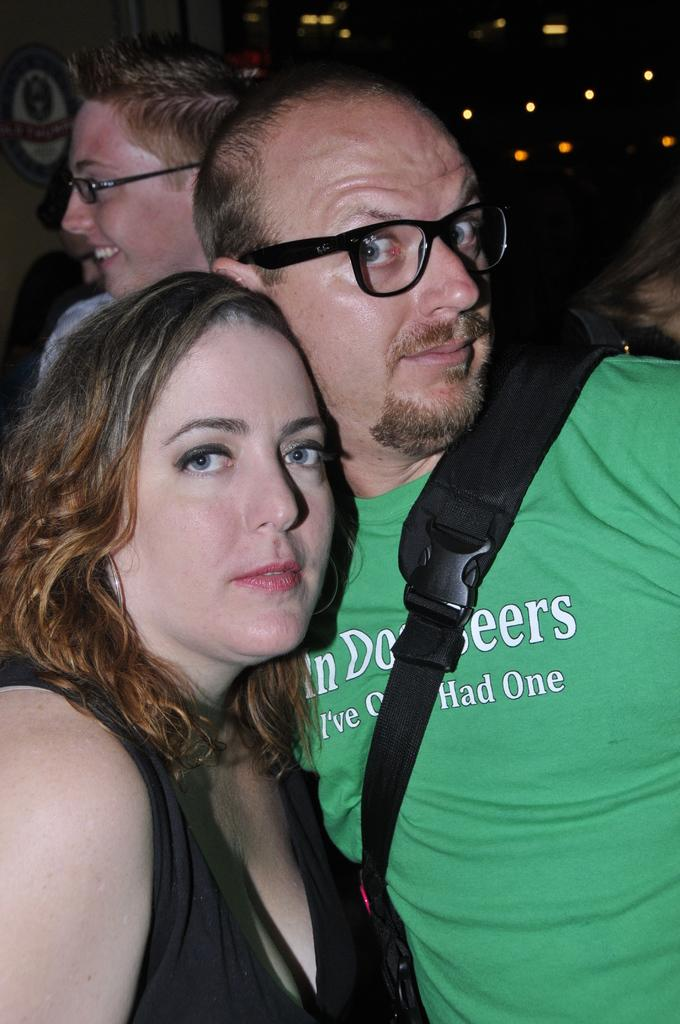How many people are present in the image? There is a man and a woman in the image, making a total of two people. What is the man carrying in the image? The man is carrying a bag on his shoulder. What can be seen in the background of the image? In the background, there are a few persons visible, and there are lights visible as well. What advice is the man giving to the woman in the image? There is no indication in the image that the man is giving advice to the woman. --- Facts: 1. There is a car in the image. 2. The car is parked on the street. 3. The car has four wheels. 4. There is a traffic light visible in the image. 5. The traffic light is red. Absurd Topics: dance, ocean, bird Conversation: What is the main subject of the image? The main subject of the image is a car. Where is the car located in the image? The car is parked on the street. How many wheels does the car have? The car has four wheels. What can be seen in the background of the image? There is a traffic light visible in the image. Reasoning: Let's think step by step in order to produce the conversation. We start by identifying the main subject in the image, which is the car. Then, we describe the car's location, noting that it is parked on the street. Next, we mention the number of wheels the car has, which is four. Finally, we acknowledge the presence of a traffic light in the background, providing additional context to the scene. Absurd Question/Answer: Can you see any birds dancing in the ocean in the image? There is no ocean or birds visible in the image; it features a car parked on the street with a traffic light in the background. 